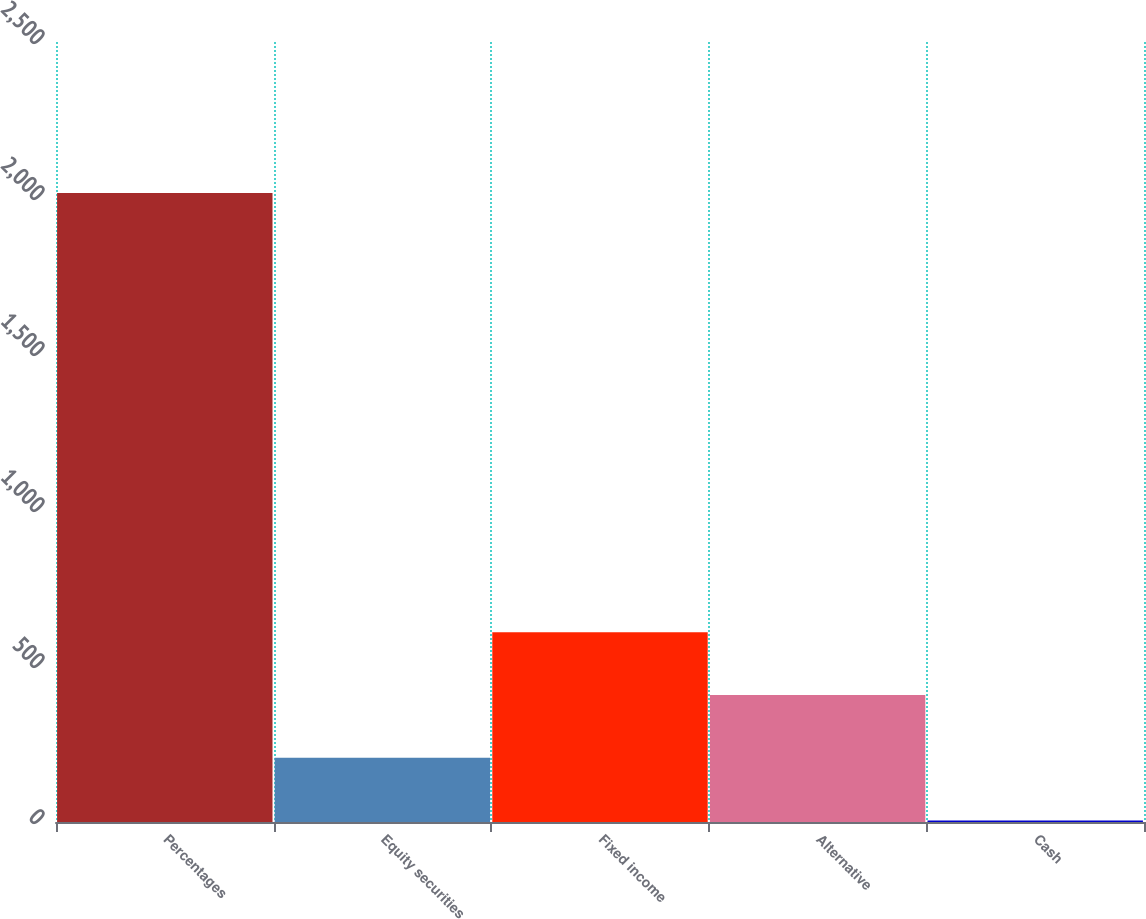Convert chart to OTSL. <chart><loc_0><loc_0><loc_500><loc_500><bar_chart><fcel>Percentages<fcel>Equity securities<fcel>Fixed income<fcel>Alternative<fcel>Cash<nl><fcel>2016<fcel>206.1<fcel>608.3<fcel>407.2<fcel>5<nl></chart> 